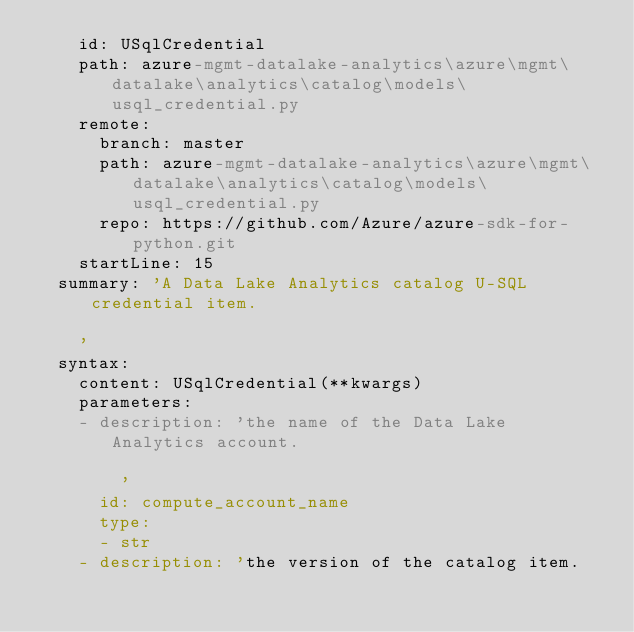<code> <loc_0><loc_0><loc_500><loc_500><_YAML_>    id: USqlCredential
    path: azure-mgmt-datalake-analytics\azure\mgmt\datalake\analytics\catalog\models\usql_credential.py
    remote:
      branch: master
      path: azure-mgmt-datalake-analytics\azure\mgmt\datalake\analytics\catalog\models\usql_credential.py
      repo: https://github.com/Azure/azure-sdk-for-python.git
    startLine: 15
  summary: 'A Data Lake Analytics catalog U-SQL credential item.

    '
  syntax:
    content: USqlCredential(**kwargs)
    parameters:
    - description: 'the name of the Data Lake Analytics account.

        '
      id: compute_account_name
      type:
      - str
    - description: 'the version of the catalog item.
</code> 